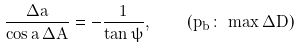<formula> <loc_0><loc_0><loc_500><loc_500>\frac { \Delta a } { \cos a \, \Delta A } = - \frac { 1 } { \tan \psi } , \quad ( p _ { b } \colon \, \max \Delta D )</formula> 